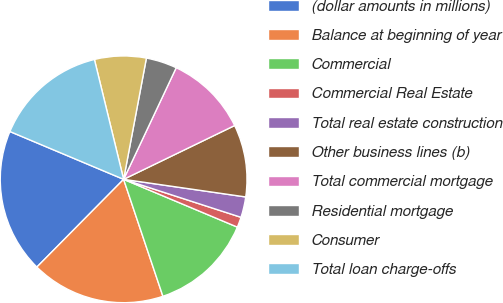<chart> <loc_0><loc_0><loc_500><loc_500><pie_chart><fcel>(dollar amounts in millions)<fcel>Balance at beginning of year<fcel>Commercial<fcel>Commercial Real Estate<fcel>Total real estate construction<fcel>Other business lines (b)<fcel>Total commercial mortgage<fcel>Residential mortgage<fcel>Consumer<fcel>Total loan charge-offs<nl><fcel>18.92%<fcel>17.57%<fcel>13.51%<fcel>1.35%<fcel>2.7%<fcel>9.46%<fcel>10.81%<fcel>4.05%<fcel>6.76%<fcel>14.86%<nl></chart> 